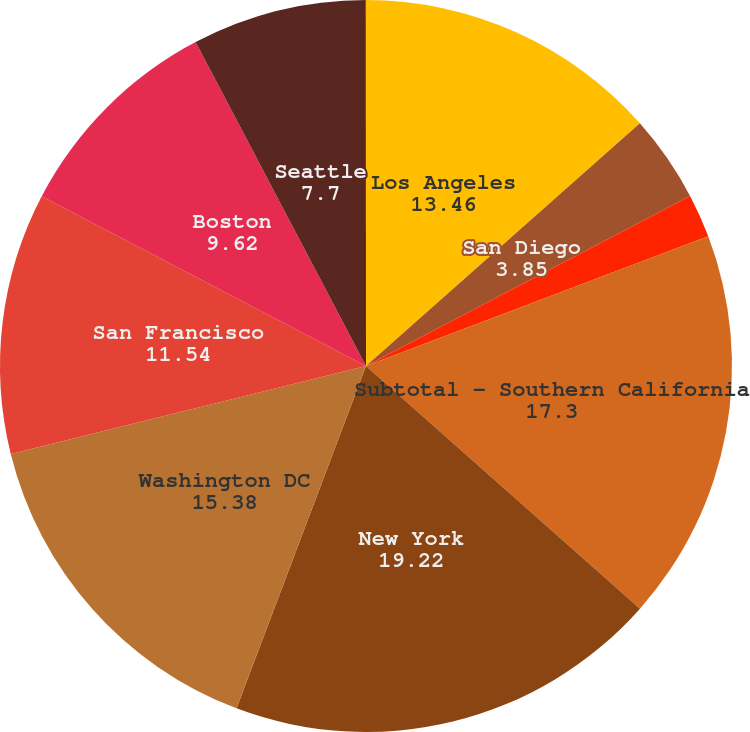<chart> <loc_0><loc_0><loc_500><loc_500><pie_chart><fcel>Los Angeles<fcel>San Diego<fcel>Orange County<fcel>Subtotal - Southern California<fcel>New York<fcel>Washington DC<fcel>San Francisco<fcel>Boston<fcel>Seattle<fcel>Other Markets<nl><fcel>13.46%<fcel>3.85%<fcel>1.93%<fcel>17.3%<fcel>19.22%<fcel>15.38%<fcel>11.54%<fcel>9.62%<fcel>7.7%<fcel>0.01%<nl></chart> 